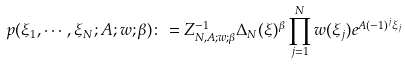<formula> <loc_0><loc_0><loc_500><loc_500>p ( \xi _ { 1 } , \cdots , \xi _ { N } ; A ; w ; \beta ) \colon = Z _ { N , A ; w ; \beta } ^ { - 1 } \Delta _ { N } ( \xi ) ^ { \beta } \prod _ { j = 1 } ^ { N } w ( \xi _ { j } ) e ^ { A ( - 1 ) ^ { j } \xi _ { j } }</formula> 